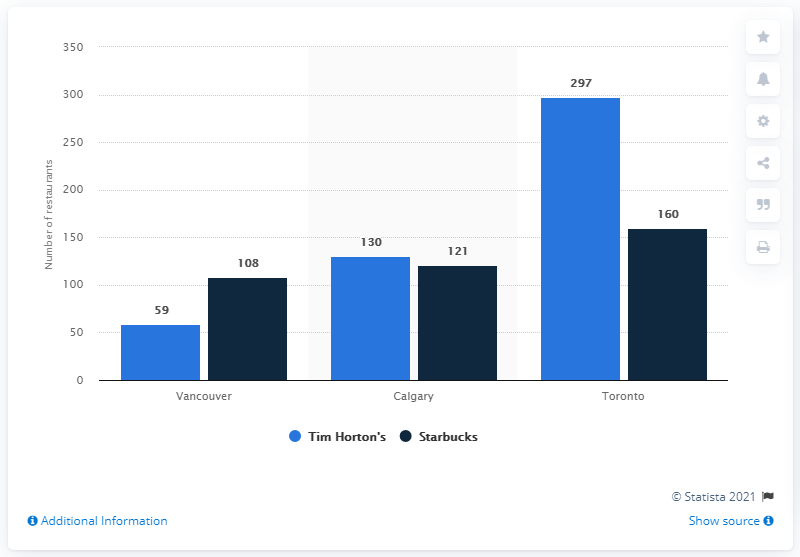How many Starbucks coffee houses were there in Vancouver in January 2015?
 108 